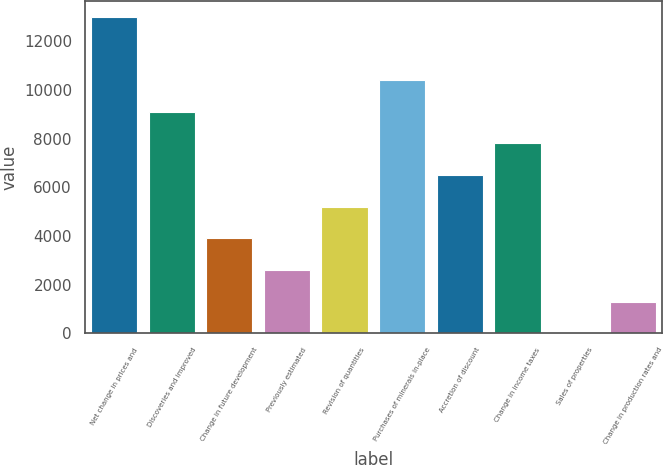Convert chart to OTSL. <chart><loc_0><loc_0><loc_500><loc_500><bar_chart><fcel>Net change in prices and<fcel>Discoveries and improved<fcel>Change in future development<fcel>Previously estimated<fcel>Revision of quantities<fcel>Purchases of minerals in-place<fcel>Accretion of discount<fcel>Change in income taxes<fcel>Sales of properties<fcel>Change in production rates and<nl><fcel>13006<fcel>9105.1<fcel>3903.9<fcel>2603.6<fcel>5204.2<fcel>10405.4<fcel>6504.5<fcel>7804.8<fcel>3<fcel>1303.3<nl></chart> 